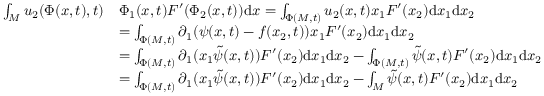<formula> <loc_0><loc_0><loc_500><loc_500>\begin{array} { r l } { \int _ { M } u _ { 2 } ( \Phi ( x , t ) , t ) } & { \Phi _ { 1 } ( x , t ) F ^ { \prime } ( \Phi _ { 2 } ( x , t ) ) d x = \int _ { \Phi ( M , t ) } u _ { 2 } ( x , t ) x _ { 1 } F ^ { \prime } ( x _ { 2 } ) d x _ { 1 } d x _ { 2 } } \\ & { = \int _ { \Phi ( M , t ) } \partial _ { 1 } ( \psi ( x , t ) - f ( x _ { 2 } , t ) ) x _ { 1 } F ^ { \prime } ( x _ { 2 } ) d x _ { 1 } d x _ { 2 } } \\ & { = \int _ { \Phi ( M , t ) } \partial _ { 1 } ( x _ { 1 } \tilde { \psi } ( x , t ) ) F ^ { \prime } ( x _ { 2 } ) d x _ { 1 } d x _ { 2 } - \int _ { \Phi ( M , t ) } \tilde { \psi } ( x , t ) F ^ { \prime } ( x _ { 2 } ) d x _ { 1 } d x _ { 2 } } \\ & { = \int _ { \Phi ( M , t ) } \partial _ { 1 } ( x _ { 1 } \tilde { \psi } ( x , t ) ) F ^ { \prime } ( x _ { 2 } ) d x _ { 1 } d x _ { 2 } - \int _ { M } \tilde { \psi } ( x , t ) F ^ { \prime } ( x _ { 2 } ) d x _ { 1 } d x _ { 2 } } \end{array}</formula> 